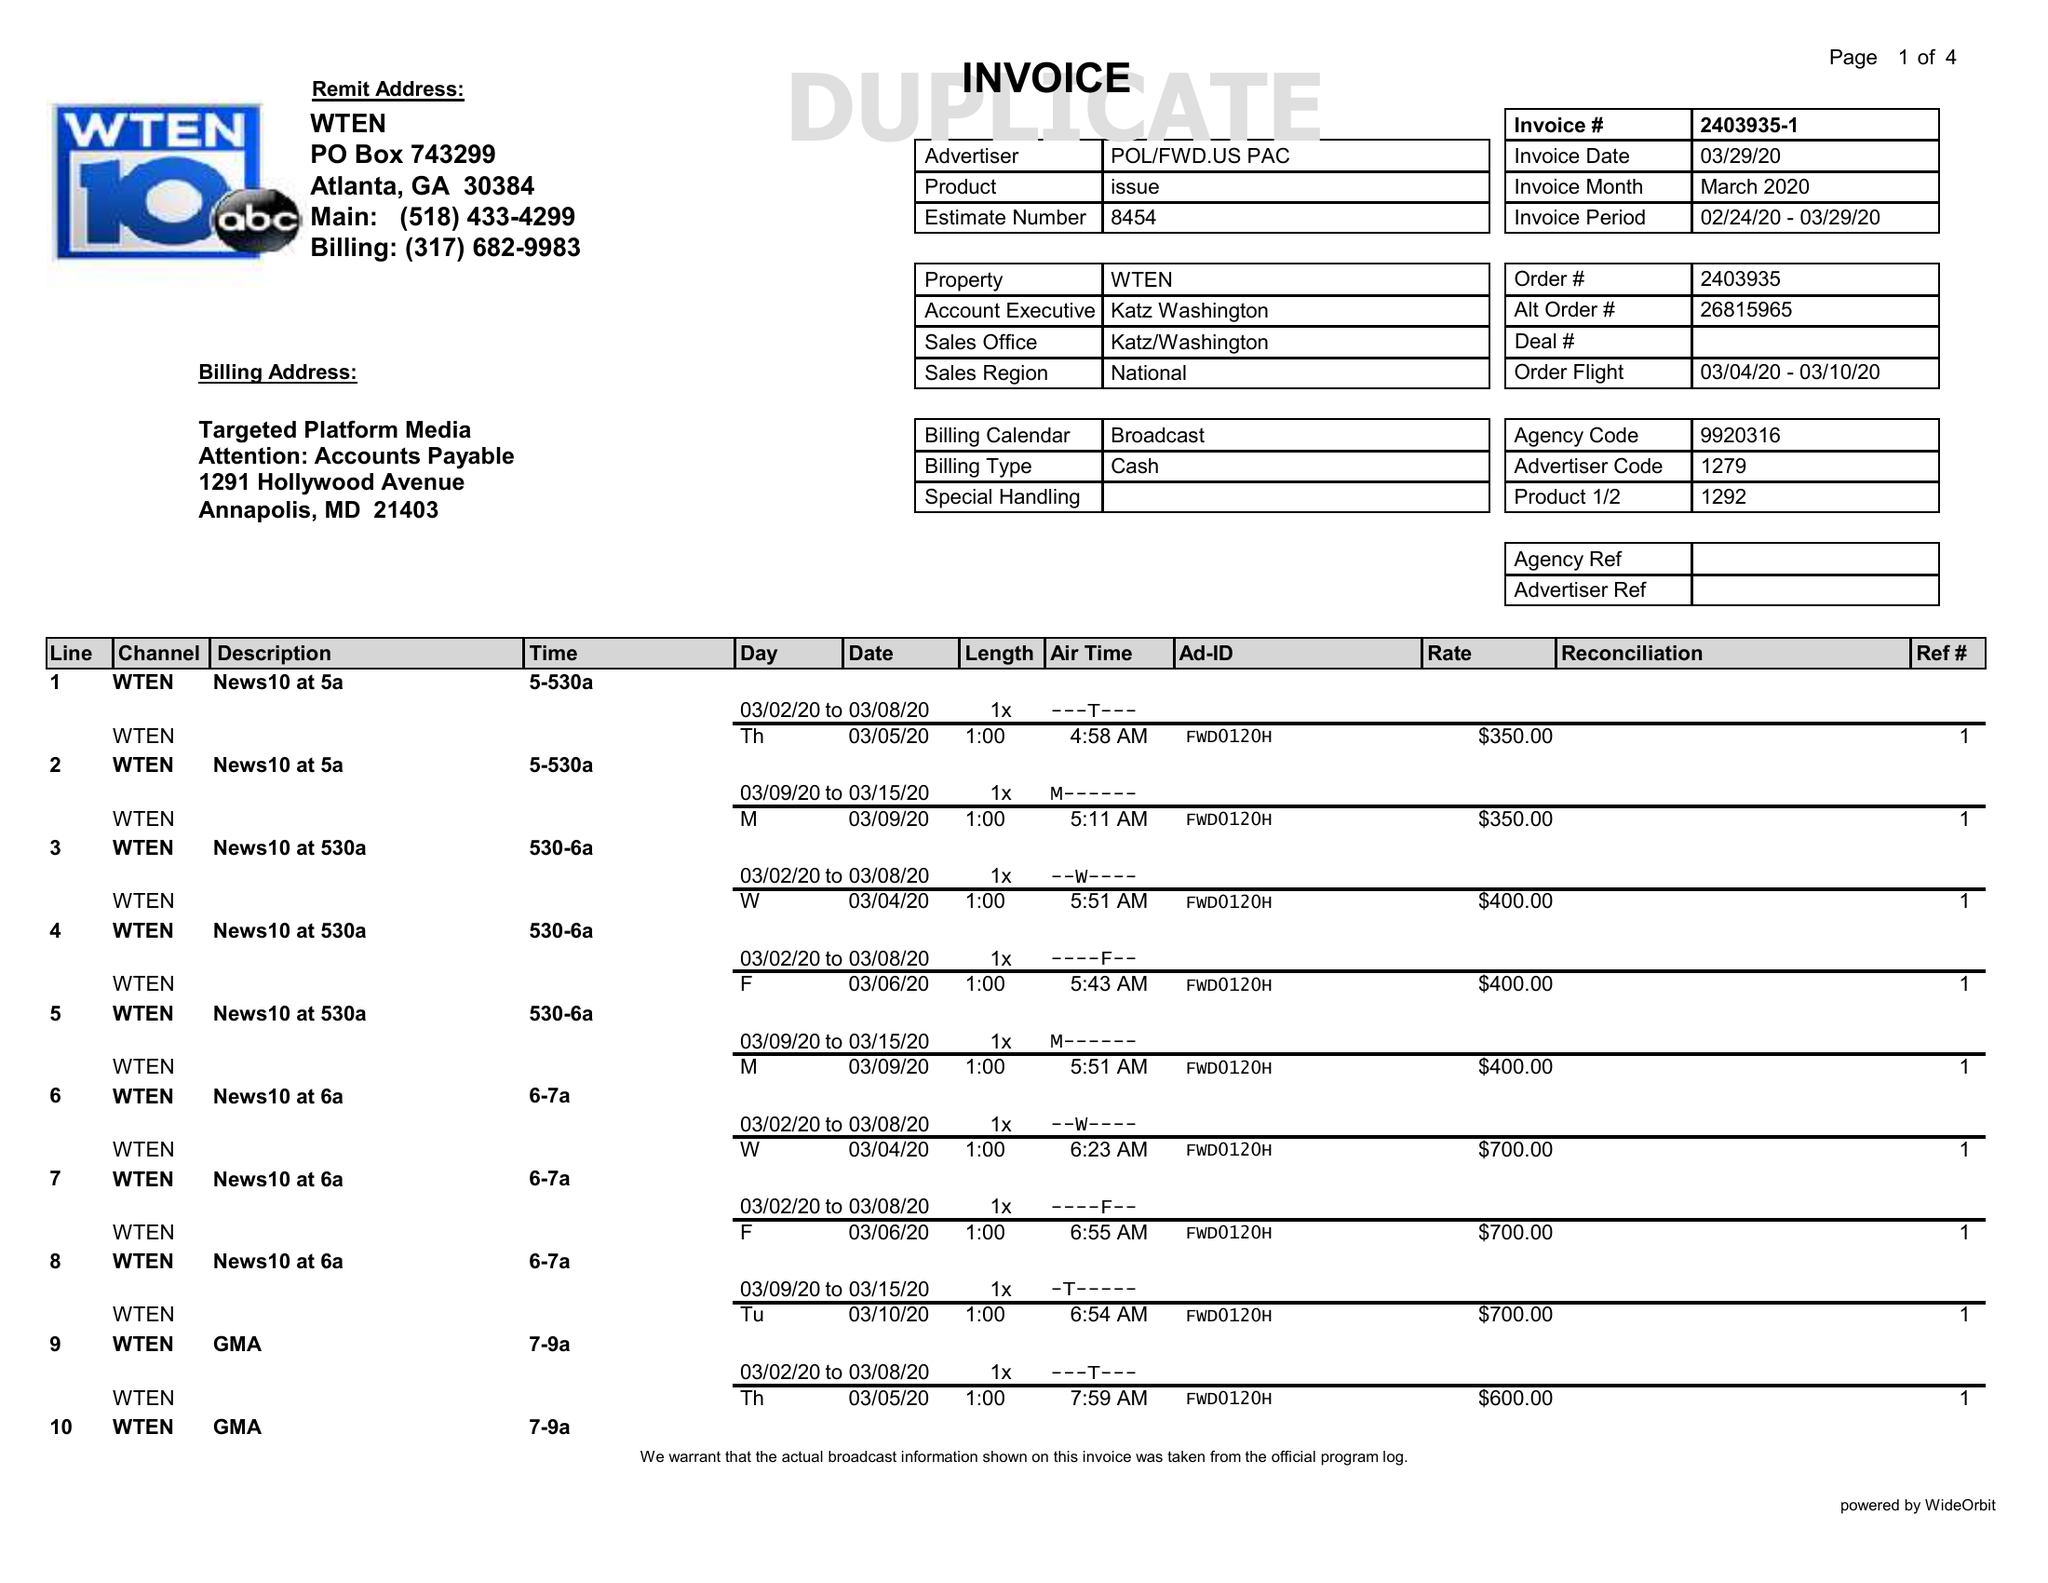What is the value for the advertiser?
Answer the question using a single word or phrase. POL/FWD.USPAC 